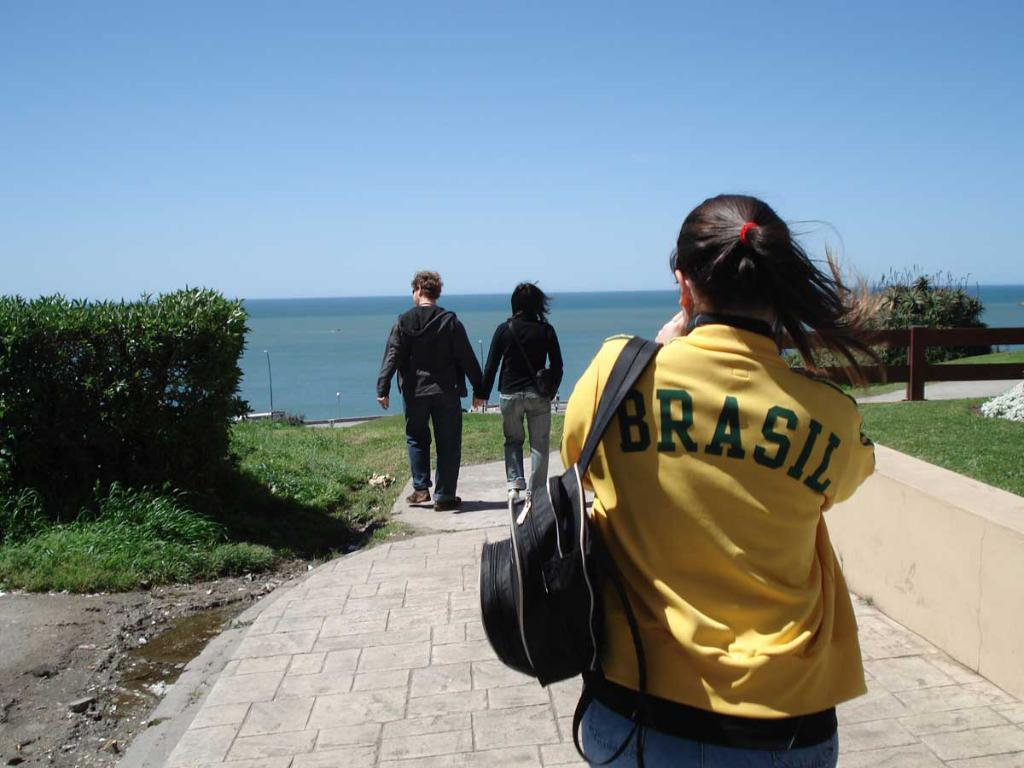How many people are walking in the image? There are three persons walking in the image. What is at the bottom of the image? There is a path at the bottom of the image. What can be seen to the left of the image? There are plants to the left of the image. What is to the right of the image? There is a railing to the right of the image. What is visible in the background of the image? There is a sea visible in the background of the image. What type of hill can be seen in the image? There is no hill present in the image; it features a path, plants, a railing, and a sea in the background. 